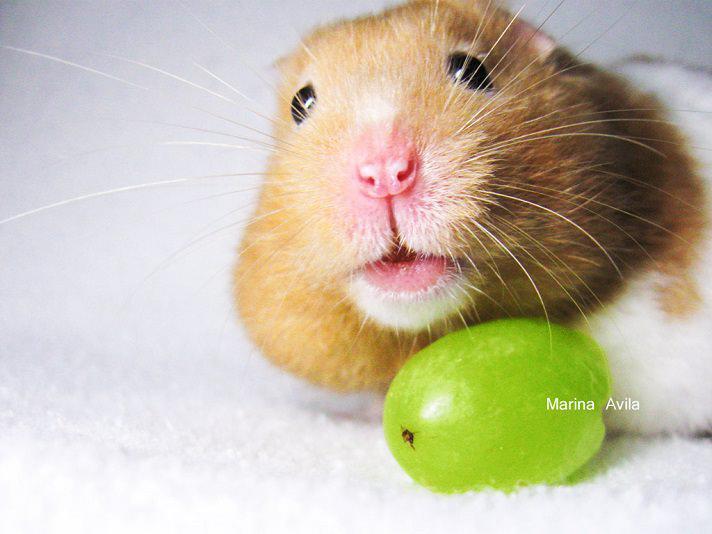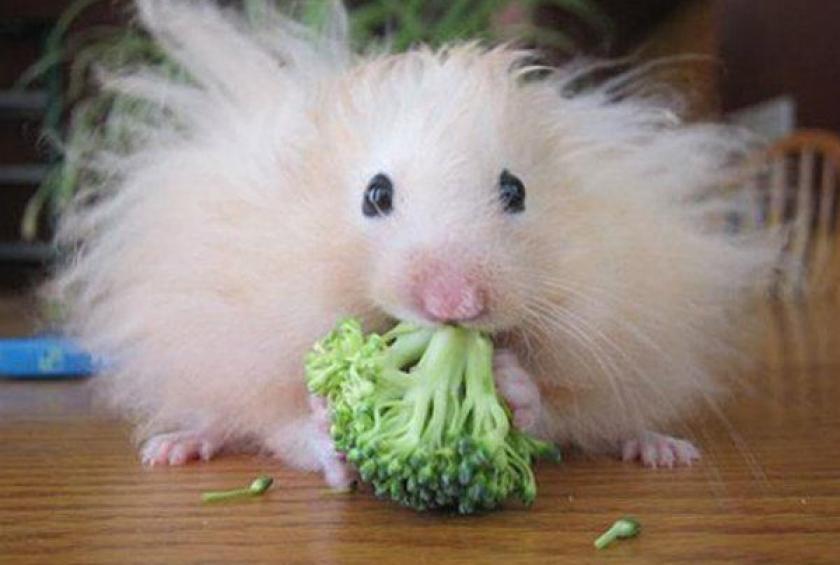The first image is the image on the left, the second image is the image on the right. Assess this claim about the two images: "The rodent in the image on the right has a piece of broccoli in front of it.". Correct or not? Answer yes or no. Yes. The first image is the image on the left, the second image is the image on the right. Given the left and right images, does the statement "A bright green broccoli floret is in front of a pet rodent." hold true? Answer yes or no. Yes. 